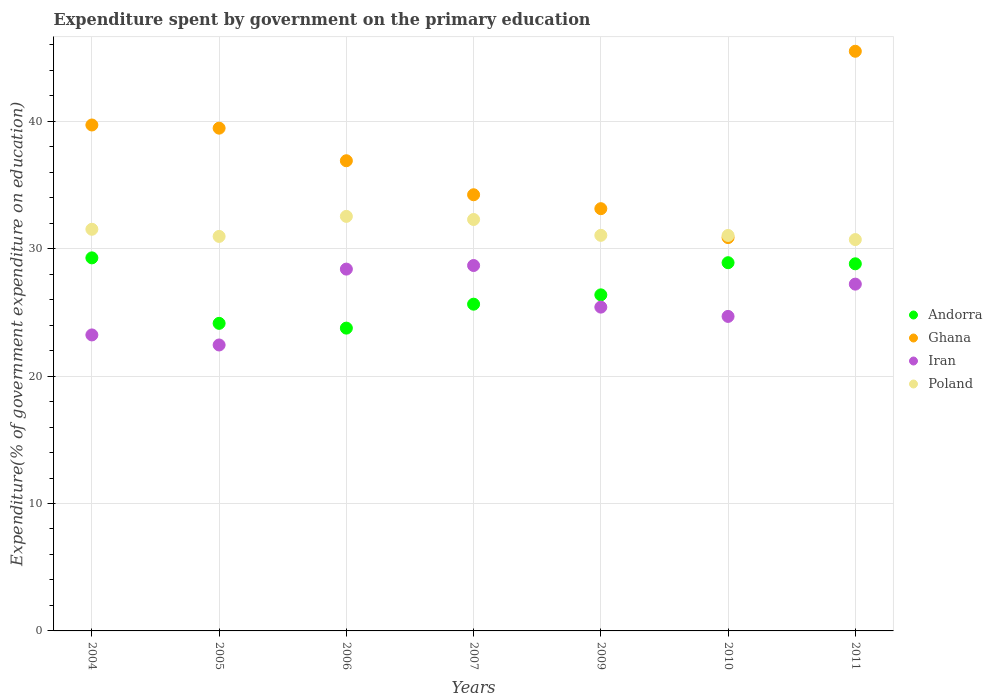What is the expenditure spent by government on the primary education in Iran in 2009?
Ensure brevity in your answer.  25.41. Across all years, what is the maximum expenditure spent by government on the primary education in Andorra?
Provide a succinct answer. 29.28. Across all years, what is the minimum expenditure spent by government on the primary education in Andorra?
Your response must be concise. 23.76. What is the total expenditure spent by government on the primary education in Ghana in the graph?
Your answer should be compact. 259.77. What is the difference between the expenditure spent by government on the primary education in Poland in 2005 and that in 2011?
Give a very brief answer. 0.25. What is the difference between the expenditure spent by government on the primary education in Andorra in 2011 and the expenditure spent by government on the primary education in Ghana in 2010?
Your answer should be compact. -2.06. What is the average expenditure spent by government on the primary education in Iran per year?
Your answer should be compact. 25.72. In the year 2007, what is the difference between the expenditure spent by government on the primary education in Poland and expenditure spent by government on the primary education in Andorra?
Offer a very short reply. 6.65. In how many years, is the expenditure spent by government on the primary education in Iran greater than 14 %?
Keep it short and to the point. 7. What is the ratio of the expenditure spent by government on the primary education in Iran in 2006 to that in 2011?
Keep it short and to the point. 1.04. What is the difference between the highest and the second highest expenditure spent by government on the primary education in Andorra?
Offer a very short reply. 0.38. What is the difference between the highest and the lowest expenditure spent by government on the primary education in Andorra?
Keep it short and to the point. 5.51. In how many years, is the expenditure spent by government on the primary education in Ghana greater than the average expenditure spent by government on the primary education in Ghana taken over all years?
Ensure brevity in your answer.  3. Is it the case that in every year, the sum of the expenditure spent by government on the primary education in Andorra and expenditure spent by government on the primary education in Iran  is greater than the sum of expenditure spent by government on the primary education in Ghana and expenditure spent by government on the primary education in Poland?
Your response must be concise. No. Is it the case that in every year, the sum of the expenditure spent by government on the primary education in Ghana and expenditure spent by government on the primary education in Andorra  is greater than the expenditure spent by government on the primary education in Poland?
Offer a terse response. Yes. Does the expenditure spent by government on the primary education in Poland monotonically increase over the years?
Offer a terse response. No. Is the expenditure spent by government on the primary education in Andorra strictly greater than the expenditure spent by government on the primary education in Ghana over the years?
Your answer should be very brief. No. Is the expenditure spent by government on the primary education in Poland strictly less than the expenditure spent by government on the primary education in Ghana over the years?
Provide a succinct answer. No. How many years are there in the graph?
Provide a succinct answer. 7. Are the values on the major ticks of Y-axis written in scientific E-notation?
Your answer should be compact. No. Does the graph contain any zero values?
Keep it short and to the point. No. Where does the legend appear in the graph?
Offer a terse response. Center right. How are the legend labels stacked?
Offer a very short reply. Vertical. What is the title of the graph?
Offer a terse response. Expenditure spent by government on the primary education. Does "Iraq" appear as one of the legend labels in the graph?
Your answer should be very brief. No. What is the label or title of the X-axis?
Your response must be concise. Years. What is the label or title of the Y-axis?
Ensure brevity in your answer.  Expenditure(% of government expenditure on education). What is the Expenditure(% of government expenditure on education) of Andorra in 2004?
Make the answer very short. 29.28. What is the Expenditure(% of government expenditure on education) of Ghana in 2004?
Your answer should be very brief. 39.7. What is the Expenditure(% of government expenditure on education) of Iran in 2004?
Keep it short and to the point. 23.23. What is the Expenditure(% of government expenditure on education) of Poland in 2004?
Ensure brevity in your answer.  31.52. What is the Expenditure(% of government expenditure on education) in Andorra in 2005?
Ensure brevity in your answer.  24.14. What is the Expenditure(% of government expenditure on education) of Ghana in 2005?
Provide a short and direct response. 39.45. What is the Expenditure(% of government expenditure on education) of Iran in 2005?
Provide a succinct answer. 22.44. What is the Expenditure(% of government expenditure on education) of Poland in 2005?
Ensure brevity in your answer.  30.96. What is the Expenditure(% of government expenditure on education) of Andorra in 2006?
Your response must be concise. 23.76. What is the Expenditure(% of government expenditure on education) in Ghana in 2006?
Provide a short and direct response. 36.9. What is the Expenditure(% of government expenditure on education) in Iran in 2006?
Make the answer very short. 28.39. What is the Expenditure(% of government expenditure on education) in Poland in 2006?
Make the answer very short. 32.53. What is the Expenditure(% of government expenditure on education) of Andorra in 2007?
Your answer should be compact. 25.64. What is the Expenditure(% of government expenditure on education) in Ghana in 2007?
Provide a short and direct response. 34.23. What is the Expenditure(% of government expenditure on education) of Iran in 2007?
Provide a succinct answer. 28.67. What is the Expenditure(% of government expenditure on education) in Poland in 2007?
Make the answer very short. 32.29. What is the Expenditure(% of government expenditure on education) in Andorra in 2009?
Offer a terse response. 26.37. What is the Expenditure(% of government expenditure on education) in Ghana in 2009?
Provide a succinct answer. 33.13. What is the Expenditure(% of government expenditure on education) in Iran in 2009?
Make the answer very short. 25.41. What is the Expenditure(% of government expenditure on education) in Poland in 2009?
Your response must be concise. 31.04. What is the Expenditure(% of government expenditure on education) in Andorra in 2010?
Keep it short and to the point. 28.9. What is the Expenditure(% of government expenditure on education) in Ghana in 2010?
Provide a succinct answer. 30.87. What is the Expenditure(% of government expenditure on education) in Iran in 2010?
Provide a short and direct response. 24.68. What is the Expenditure(% of government expenditure on education) of Poland in 2010?
Your response must be concise. 31.03. What is the Expenditure(% of government expenditure on education) in Andorra in 2011?
Ensure brevity in your answer.  28.81. What is the Expenditure(% of government expenditure on education) in Ghana in 2011?
Your answer should be compact. 45.49. What is the Expenditure(% of government expenditure on education) in Iran in 2011?
Make the answer very short. 27.21. What is the Expenditure(% of government expenditure on education) of Poland in 2011?
Keep it short and to the point. 30.71. Across all years, what is the maximum Expenditure(% of government expenditure on education) in Andorra?
Keep it short and to the point. 29.28. Across all years, what is the maximum Expenditure(% of government expenditure on education) in Ghana?
Your answer should be very brief. 45.49. Across all years, what is the maximum Expenditure(% of government expenditure on education) in Iran?
Keep it short and to the point. 28.67. Across all years, what is the maximum Expenditure(% of government expenditure on education) of Poland?
Provide a succinct answer. 32.53. Across all years, what is the minimum Expenditure(% of government expenditure on education) of Andorra?
Keep it short and to the point. 23.76. Across all years, what is the minimum Expenditure(% of government expenditure on education) of Ghana?
Your answer should be compact. 30.87. Across all years, what is the minimum Expenditure(% of government expenditure on education) of Iran?
Keep it short and to the point. 22.44. Across all years, what is the minimum Expenditure(% of government expenditure on education) in Poland?
Provide a short and direct response. 30.71. What is the total Expenditure(% of government expenditure on education) of Andorra in the graph?
Ensure brevity in your answer.  186.89. What is the total Expenditure(% of government expenditure on education) in Ghana in the graph?
Provide a succinct answer. 259.77. What is the total Expenditure(% of government expenditure on education) of Iran in the graph?
Your answer should be compact. 180.04. What is the total Expenditure(% of government expenditure on education) of Poland in the graph?
Ensure brevity in your answer.  220.08. What is the difference between the Expenditure(% of government expenditure on education) of Andorra in 2004 and that in 2005?
Keep it short and to the point. 5.14. What is the difference between the Expenditure(% of government expenditure on education) of Ghana in 2004 and that in 2005?
Your answer should be compact. 0.25. What is the difference between the Expenditure(% of government expenditure on education) of Iran in 2004 and that in 2005?
Offer a terse response. 0.79. What is the difference between the Expenditure(% of government expenditure on education) in Poland in 2004 and that in 2005?
Give a very brief answer. 0.56. What is the difference between the Expenditure(% of government expenditure on education) of Andorra in 2004 and that in 2006?
Give a very brief answer. 5.51. What is the difference between the Expenditure(% of government expenditure on education) in Ghana in 2004 and that in 2006?
Ensure brevity in your answer.  2.81. What is the difference between the Expenditure(% of government expenditure on education) of Iran in 2004 and that in 2006?
Ensure brevity in your answer.  -5.17. What is the difference between the Expenditure(% of government expenditure on education) of Poland in 2004 and that in 2006?
Offer a terse response. -1.01. What is the difference between the Expenditure(% of government expenditure on education) of Andorra in 2004 and that in 2007?
Offer a very short reply. 3.63. What is the difference between the Expenditure(% of government expenditure on education) of Ghana in 2004 and that in 2007?
Offer a very short reply. 5.47. What is the difference between the Expenditure(% of government expenditure on education) of Iran in 2004 and that in 2007?
Offer a very short reply. -5.45. What is the difference between the Expenditure(% of government expenditure on education) of Poland in 2004 and that in 2007?
Provide a short and direct response. -0.77. What is the difference between the Expenditure(% of government expenditure on education) in Andorra in 2004 and that in 2009?
Provide a succinct answer. 2.9. What is the difference between the Expenditure(% of government expenditure on education) in Ghana in 2004 and that in 2009?
Make the answer very short. 6.57. What is the difference between the Expenditure(% of government expenditure on education) in Iran in 2004 and that in 2009?
Keep it short and to the point. -2.18. What is the difference between the Expenditure(% of government expenditure on education) of Poland in 2004 and that in 2009?
Keep it short and to the point. 0.48. What is the difference between the Expenditure(% of government expenditure on education) in Andorra in 2004 and that in 2010?
Your answer should be very brief. 0.38. What is the difference between the Expenditure(% of government expenditure on education) of Ghana in 2004 and that in 2010?
Offer a very short reply. 8.84. What is the difference between the Expenditure(% of government expenditure on education) in Iran in 2004 and that in 2010?
Your answer should be compact. -1.45. What is the difference between the Expenditure(% of government expenditure on education) of Poland in 2004 and that in 2010?
Offer a terse response. 0.48. What is the difference between the Expenditure(% of government expenditure on education) in Andorra in 2004 and that in 2011?
Keep it short and to the point. 0.47. What is the difference between the Expenditure(% of government expenditure on education) in Ghana in 2004 and that in 2011?
Make the answer very short. -5.79. What is the difference between the Expenditure(% of government expenditure on education) of Iran in 2004 and that in 2011?
Keep it short and to the point. -3.99. What is the difference between the Expenditure(% of government expenditure on education) of Poland in 2004 and that in 2011?
Provide a short and direct response. 0.81. What is the difference between the Expenditure(% of government expenditure on education) of Andorra in 2005 and that in 2006?
Make the answer very short. 0.37. What is the difference between the Expenditure(% of government expenditure on education) of Ghana in 2005 and that in 2006?
Your answer should be very brief. 2.56. What is the difference between the Expenditure(% of government expenditure on education) of Iran in 2005 and that in 2006?
Offer a terse response. -5.95. What is the difference between the Expenditure(% of government expenditure on education) in Poland in 2005 and that in 2006?
Your answer should be very brief. -1.57. What is the difference between the Expenditure(% of government expenditure on education) of Andorra in 2005 and that in 2007?
Keep it short and to the point. -1.5. What is the difference between the Expenditure(% of government expenditure on education) in Ghana in 2005 and that in 2007?
Give a very brief answer. 5.23. What is the difference between the Expenditure(% of government expenditure on education) of Iran in 2005 and that in 2007?
Your answer should be very brief. -6.24. What is the difference between the Expenditure(% of government expenditure on education) in Poland in 2005 and that in 2007?
Offer a terse response. -1.33. What is the difference between the Expenditure(% of government expenditure on education) of Andorra in 2005 and that in 2009?
Your answer should be compact. -2.24. What is the difference between the Expenditure(% of government expenditure on education) of Ghana in 2005 and that in 2009?
Offer a very short reply. 6.32. What is the difference between the Expenditure(% of government expenditure on education) in Iran in 2005 and that in 2009?
Keep it short and to the point. -2.97. What is the difference between the Expenditure(% of government expenditure on education) of Poland in 2005 and that in 2009?
Make the answer very short. -0.08. What is the difference between the Expenditure(% of government expenditure on education) of Andorra in 2005 and that in 2010?
Offer a very short reply. -4.76. What is the difference between the Expenditure(% of government expenditure on education) of Ghana in 2005 and that in 2010?
Offer a terse response. 8.59. What is the difference between the Expenditure(% of government expenditure on education) in Iran in 2005 and that in 2010?
Your response must be concise. -2.24. What is the difference between the Expenditure(% of government expenditure on education) of Poland in 2005 and that in 2010?
Offer a terse response. -0.07. What is the difference between the Expenditure(% of government expenditure on education) of Andorra in 2005 and that in 2011?
Your answer should be compact. -4.67. What is the difference between the Expenditure(% of government expenditure on education) of Ghana in 2005 and that in 2011?
Give a very brief answer. -6.03. What is the difference between the Expenditure(% of government expenditure on education) in Iran in 2005 and that in 2011?
Your response must be concise. -4.77. What is the difference between the Expenditure(% of government expenditure on education) in Poland in 2005 and that in 2011?
Your answer should be compact. 0.25. What is the difference between the Expenditure(% of government expenditure on education) of Andorra in 2006 and that in 2007?
Keep it short and to the point. -1.88. What is the difference between the Expenditure(% of government expenditure on education) of Ghana in 2006 and that in 2007?
Give a very brief answer. 2.67. What is the difference between the Expenditure(% of government expenditure on education) of Iran in 2006 and that in 2007?
Make the answer very short. -0.28. What is the difference between the Expenditure(% of government expenditure on education) of Poland in 2006 and that in 2007?
Ensure brevity in your answer.  0.24. What is the difference between the Expenditure(% of government expenditure on education) in Andorra in 2006 and that in 2009?
Offer a very short reply. -2.61. What is the difference between the Expenditure(% of government expenditure on education) of Ghana in 2006 and that in 2009?
Ensure brevity in your answer.  3.76. What is the difference between the Expenditure(% of government expenditure on education) of Iran in 2006 and that in 2009?
Offer a very short reply. 2.98. What is the difference between the Expenditure(% of government expenditure on education) of Poland in 2006 and that in 2009?
Provide a succinct answer. 1.49. What is the difference between the Expenditure(% of government expenditure on education) of Andorra in 2006 and that in 2010?
Your response must be concise. -5.13. What is the difference between the Expenditure(% of government expenditure on education) in Ghana in 2006 and that in 2010?
Your answer should be very brief. 6.03. What is the difference between the Expenditure(% of government expenditure on education) in Iran in 2006 and that in 2010?
Provide a short and direct response. 3.71. What is the difference between the Expenditure(% of government expenditure on education) in Poland in 2006 and that in 2010?
Give a very brief answer. 1.5. What is the difference between the Expenditure(% of government expenditure on education) of Andorra in 2006 and that in 2011?
Keep it short and to the point. -5.05. What is the difference between the Expenditure(% of government expenditure on education) of Ghana in 2006 and that in 2011?
Keep it short and to the point. -8.59. What is the difference between the Expenditure(% of government expenditure on education) in Iran in 2006 and that in 2011?
Provide a succinct answer. 1.18. What is the difference between the Expenditure(% of government expenditure on education) in Poland in 2006 and that in 2011?
Your answer should be very brief. 1.82. What is the difference between the Expenditure(% of government expenditure on education) of Andorra in 2007 and that in 2009?
Ensure brevity in your answer.  -0.73. What is the difference between the Expenditure(% of government expenditure on education) of Ghana in 2007 and that in 2009?
Your answer should be compact. 1.09. What is the difference between the Expenditure(% of government expenditure on education) of Iran in 2007 and that in 2009?
Provide a short and direct response. 3.27. What is the difference between the Expenditure(% of government expenditure on education) in Poland in 2007 and that in 2009?
Your answer should be very brief. 1.24. What is the difference between the Expenditure(% of government expenditure on education) of Andorra in 2007 and that in 2010?
Provide a succinct answer. -3.25. What is the difference between the Expenditure(% of government expenditure on education) in Ghana in 2007 and that in 2010?
Give a very brief answer. 3.36. What is the difference between the Expenditure(% of government expenditure on education) in Iran in 2007 and that in 2010?
Give a very brief answer. 3.99. What is the difference between the Expenditure(% of government expenditure on education) of Poland in 2007 and that in 2010?
Keep it short and to the point. 1.25. What is the difference between the Expenditure(% of government expenditure on education) in Andorra in 2007 and that in 2011?
Your answer should be very brief. -3.17. What is the difference between the Expenditure(% of government expenditure on education) in Ghana in 2007 and that in 2011?
Give a very brief answer. -11.26. What is the difference between the Expenditure(% of government expenditure on education) of Iran in 2007 and that in 2011?
Make the answer very short. 1.46. What is the difference between the Expenditure(% of government expenditure on education) in Poland in 2007 and that in 2011?
Your answer should be compact. 1.58. What is the difference between the Expenditure(% of government expenditure on education) of Andorra in 2009 and that in 2010?
Offer a terse response. -2.52. What is the difference between the Expenditure(% of government expenditure on education) of Ghana in 2009 and that in 2010?
Ensure brevity in your answer.  2.27. What is the difference between the Expenditure(% of government expenditure on education) in Iran in 2009 and that in 2010?
Keep it short and to the point. 0.73. What is the difference between the Expenditure(% of government expenditure on education) of Poland in 2009 and that in 2010?
Provide a succinct answer. 0.01. What is the difference between the Expenditure(% of government expenditure on education) of Andorra in 2009 and that in 2011?
Your response must be concise. -2.44. What is the difference between the Expenditure(% of government expenditure on education) in Ghana in 2009 and that in 2011?
Ensure brevity in your answer.  -12.35. What is the difference between the Expenditure(% of government expenditure on education) of Iran in 2009 and that in 2011?
Offer a very short reply. -1.8. What is the difference between the Expenditure(% of government expenditure on education) of Poland in 2009 and that in 2011?
Offer a very short reply. 0.33. What is the difference between the Expenditure(% of government expenditure on education) in Andorra in 2010 and that in 2011?
Ensure brevity in your answer.  0.09. What is the difference between the Expenditure(% of government expenditure on education) in Ghana in 2010 and that in 2011?
Give a very brief answer. -14.62. What is the difference between the Expenditure(% of government expenditure on education) in Iran in 2010 and that in 2011?
Ensure brevity in your answer.  -2.53. What is the difference between the Expenditure(% of government expenditure on education) of Poland in 2010 and that in 2011?
Your answer should be compact. 0.32. What is the difference between the Expenditure(% of government expenditure on education) of Andorra in 2004 and the Expenditure(% of government expenditure on education) of Ghana in 2005?
Provide a succinct answer. -10.18. What is the difference between the Expenditure(% of government expenditure on education) in Andorra in 2004 and the Expenditure(% of government expenditure on education) in Iran in 2005?
Give a very brief answer. 6.84. What is the difference between the Expenditure(% of government expenditure on education) of Andorra in 2004 and the Expenditure(% of government expenditure on education) of Poland in 2005?
Your response must be concise. -1.68. What is the difference between the Expenditure(% of government expenditure on education) of Ghana in 2004 and the Expenditure(% of government expenditure on education) of Iran in 2005?
Keep it short and to the point. 17.26. What is the difference between the Expenditure(% of government expenditure on education) of Ghana in 2004 and the Expenditure(% of government expenditure on education) of Poland in 2005?
Your answer should be compact. 8.74. What is the difference between the Expenditure(% of government expenditure on education) in Iran in 2004 and the Expenditure(% of government expenditure on education) in Poland in 2005?
Ensure brevity in your answer.  -7.73. What is the difference between the Expenditure(% of government expenditure on education) in Andorra in 2004 and the Expenditure(% of government expenditure on education) in Ghana in 2006?
Ensure brevity in your answer.  -7.62. What is the difference between the Expenditure(% of government expenditure on education) in Andorra in 2004 and the Expenditure(% of government expenditure on education) in Iran in 2006?
Provide a short and direct response. 0.88. What is the difference between the Expenditure(% of government expenditure on education) in Andorra in 2004 and the Expenditure(% of government expenditure on education) in Poland in 2006?
Your response must be concise. -3.26. What is the difference between the Expenditure(% of government expenditure on education) in Ghana in 2004 and the Expenditure(% of government expenditure on education) in Iran in 2006?
Offer a terse response. 11.31. What is the difference between the Expenditure(% of government expenditure on education) in Ghana in 2004 and the Expenditure(% of government expenditure on education) in Poland in 2006?
Your response must be concise. 7.17. What is the difference between the Expenditure(% of government expenditure on education) in Iran in 2004 and the Expenditure(% of government expenditure on education) in Poland in 2006?
Ensure brevity in your answer.  -9.3. What is the difference between the Expenditure(% of government expenditure on education) of Andorra in 2004 and the Expenditure(% of government expenditure on education) of Ghana in 2007?
Provide a succinct answer. -4.95. What is the difference between the Expenditure(% of government expenditure on education) of Andorra in 2004 and the Expenditure(% of government expenditure on education) of Iran in 2007?
Provide a succinct answer. 0.6. What is the difference between the Expenditure(% of government expenditure on education) in Andorra in 2004 and the Expenditure(% of government expenditure on education) in Poland in 2007?
Ensure brevity in your answer.  -3.01. What is the difference between the Expenditure(% of government expenditure on education) in Ghana in 2004 and the Expenditure(% of government expenditure on education) in Iran in 2007?
Offer a terse response. 11.03. What is the difference between the Expenditure(% of government expenditure on education) of Ghana in 2004 and the Expenditure(% of government expenditure on education) of Poland in 2007?
Keep it short and to the point. 7.42. What is the difference between the Expenditure(% of government expenditure on education) in Iran in 2004 and the Expenditure(% of government expenditure on education) in Poland in 2007?
Give a very brief answer. -9.06. What is the difference between the Expenditure(% of government expenditure on education) of Andorra in 2004 and the Expenditure(% of government expenditure on education) of Ghana in 2009?
Ensure brevity in your answer.  -3.86. What is the difference between the Expenditure(% of government expenditure on education) in Andorra in 2004 and the Expenditure(% of government expenditure on education) in Iran in 2009?
Your answer should be compact. 3.87. What is the difference between the Expenditure(% of government expenditure on education) of Andorra in 2004 and the Expenditure(% of government expenditure on education) of Poland in 2009?
Offer a terse response. -1.77. What is the difference between the Expenditure(% of government expenditure on education) in Ghana in 2004 and the Expenditure(% of government expenditure on education) in Iran in 2009?
Give a very brief answer. 14.29. What is the difference between the Expenditure(% of government expenditure on education) of Ghana in 2004 and the Expenditure(% of government expenditure on education) of Poland in 2009?
Your answer should be compact. 8.66. What is the difference between the Expenditure(% of government expenditure on education) in Iran in 2004 and the Expenditure(% of government expenditure on education) in Poland in 2009?
Offer a very short reply. -7.82. What is the difference between the Expenditure(% of government expenditure on education) of Andorra in 2004 and the Expenditure(% of government expenditure on education) of Ghana in 2010?
Make the answer very short. -1.59. What is the difference between the Expenditure(% of government expenditure on education) in Andorra in 2004 and the Expenditure(% of government expenditure on education) in Iran in 2010?
Make the answer very short. 4.59. What is the difference between the Expenditure(% of government expenditure on education) of Andorra in 2004 and the Expenditure(% of government expenditure on education) of Poland in 2010?
Your answer should be compact. -1.76. What is the difference between the Expenditure(% of government expenditure on education) of Ghana in 2004 and the Expenditure(% of government expenditure on education) of Iran in 2010?
Your answer should be compact. 15.02. What is the difference between the Expenditure(% of government expenditure on education) in Ghana in 2004 and the Expenditure(% of government expenditure on education) in Poland in 2010?
Ensure brevity in your answer.  8.67. What is the difference between the Expenditure(% of government expenditure on education) in Iran in 2004 and the Expenditure(% of government expenditure on education) in Poland in 2010?
Provide a short and direct response. -7.81. What is the difference between the Expenditure(% of government expenditure on education) in Andorra in 2004 and the Expenditure(% of government expenditure on education) in Ghana in 2011?
Your answer should be very brief. -16.21. What is the difference between the Expenditure(% of government expenditure on education) of Andorra in 2004 and the Expenditure(% of government expenditure on education) of Iran in 2011?
Offer a very short reply. 2.06. What is the difference between the Expenditure(% of government expenditure on education) of Andorra in 2004 and the Expenditure(% of government expenditure on education) of Poland in 2011?
Make the answer very short. -1.44. What is the difference between the Expenditure(% of government expenditure on education) of Ghana in 2004 and the Expenditure(% of government expenditure on education) of Iran in 2011?
Provide a succinct answer. 12.49. What is the difference between the Expenditure(% of government expenditure on education) of Ghana in 2004 and the Expenditure(% of government expenditure on education) of Poland in 2011?
Your response must be concise. 8.99. What is the difference between the Expenditure(% of government expenditure on education) in Iran in 2004 and the Expenditure(% of government expenditure on education) in Poland in 2011?
Your answer should be compact. -7.48. What is the difference between the Expenditure(% of government expenditure on education) in Andorra in 2005 and the Expenditure(% of government expenditure on education) in Ghana in 2006?
Keep it short and to the point. -12.76. What is the difference between the Expenditure(% of government expenditure on education) in Andorra in 2005 and the Expenditure(% of government expenditure on education) in Iran in 2006?
Your answer should be very brief. -4.26. What is the difference between the Expenditure(% of government expenditure on education) in Andorra in 2005 and the Expenditure(% of government expenditure on education) in Poland in 2006?
Make the answer very short. -8.39. What is the difference between the Expenditure(% of government expenditure on education) in Ghana in 2005 and the Expenditure(% of government expenditure on education) in Iran in 2006?
Ensure brevity in your answer.  11.06. What is the difference between the Expenditure(% of government expenditure on education) of Ghana in 2005 and the Expenditure(% of government expenditure on education) of Poland in 2006?
Offer a terse response. 6.92. What is the difference between the Expenditure(% of government expenditure on education) in Iran in 2005 and the Expenditure(% of government expenditure on education) in Poland in 2006?
Offer a very short reply. -10.09. What is the difference between the Expenditure(% of government expenditure on education) of Andorra in 2005 and the Expenditure(% of government expenditure on education) of Ghana in 2007?
Provide a short and direct response. -10.09. What is the difference between the Expenditure(% of government expenditure on education) in Andorra in 2005 and the Expenditure(% of government expenditure on education) in Iran in 2007?
Ensure brevity in your answer.  -4.54. What is the difference between the Expenditure(% of government expenditure on education) in Andorra in 2005 and the Expenditure(% of government expenditure on education) in Poland in 2007?
Your answer should be compact. -8.15. What is the difference between the Expenditure(% of government expenditure on education) of Ghana in 2005 and the Expenditure(% of government expenditure on education) of Iran in 2007?
Provide a short and direct response. 10.78. What is the difference between the Expenditure(% of government expenditure on education) of Ghana in 2005 and the Expenditure(% of government expenditure on education) of Poland in 2007?
Offer a terse response. 7.17. What is the difference between the Expenditure(% of government expenditure on education) of Iran in 2005 and the Expenditure(% of government expenditure on education) of Poland in 2007?
Make the answer very short. -9.85. What is the difference between the Expenditure(% of government expenditure on education) in Andorra in 2005 and the Expenditure(% of government expenditure on education) in Ghana in 2009?
Offer a very short reply. -9. What is the difference between the Expenditure(% of government expenditure on education) of Andorra in 2005 and the Expenditure(% of government expenditure on education) of Iran in 2009?
Offer a very short reply. -1.27. What is the difference between the Expenditure(% of government expenditure on education) of Andorra in 2005 and the Expenditure(% of government expenditure on education) of Poland in 2009?
Provide a succinct answer. -6.91. What is the difference between the Expenditure(% of government expenditure on education) of Ghana in 2005 and the Expenditure(% of government expenditure on education) of Iran in 2009?
Offer a terse response. 14.04. What is the difference between the Expenditure(% of government expenditure on education) in Ghana in 2005 and the Expenditure(% of government expenditure on education) in Poland in 2009?
Provide a short and direct response. 8.41. What is the difference between the Expenditure(% of government expenditure on education) in Iran in 2005 and the Expenditure(% of government expenditure on education) in Poland in 2009?
Give a very brief answer. -8.6. What is the difference between the Expenditure(% of government expenditure on education) in Andorra in 2005 and the Expenditure(% of government expenditure on education) in Ghana in 2010?
Offer a terse response. -6.73. What is the difference between the Expenditure(% of government expenditure on education) in Andorra in 2005 and the Expenditure(% of government expenditure on education) in Iran in 2010?
Your answer should be very brief. -0.54. What is the difference between the Expenditure(% of government expenditure on education) of Andorra in 2005 and the Expenditure(% of government expenditure on education) of Poland in 2010?
Offer a terse response. -6.9. What is the difference between the Expenditure(% of government expenditure on education) in Ghana in 2005 and the Expenditure(% of government expenditure on education) in Iran in 2010?
Make the answer very short. 14.77. What is the difference between the Expenditure(% of government expenditure on education) of Ghana in 2005 and the Expenditure(% of government expenditure on education) of Poland in 2010?
Provide a short and direct response. 8.42. What is the difference between the Expenditure(% of government expenditure on education) in Iran in 2005 and the Expenditure(% of government expenditure on education) in Poland in 2010?
Make the answer very short. -8.59. What is the difference between the Expenditure(% of government expenditure on education) in Andorra in 2005 and the Expenditure(% of government expenditure on education) in Ghana in 2011?
Your answer should be compact. -21.35. What is the difference between the Expenditure(% of government expenditure on education) of Andorra in 2005 and the Expenditure(% of government expenditure on education) of Iran in 2011?
Your answer should be very brief. -3.08. What is the difference between the Expenditure(% of government expenditure on education) of Andorra in 2005 and the Expenditure(% of government expenditure on education) of Poland in 2011?
Ensure brevity in your answer.  -6.57. What is the difference between the Expenditure(% of government expenditure on education) of Ghana in 2005 and the Expenditure(% of government expenditure on education) of Iran in 2011?
Your response must be concise. 12.24. What is the difference between the Expenditure(% of government expenditure on education) in Ghana in 2005 and the Expenditure(% of government expenditure on education) in Poland in 2011?
Your answer should be compact. 8.74. What is the difference between the Expenditure(% of government expenditure on education) of Iran in 2005 and the Expenditure(% of government expenditure on education) of Poland in 2011?
Provide a succinct answer. -8.27. What is the difference between the Expenditure(% of government expenditure on education) of Andorra in 2006 and the Expenditure(% of government expenditure on education) of Ghana in 2007?
Keep it short and to the point. -10.47. What is the difference between the Expenditure(% of government expenditure on education) in Andorra in 2006 and the Expenditure(% of government expenditure on education) in Iran in 2007?
Offer a terse response. -4.91. What is the difference between the Expenditure(% of government expenditure on education) of Andorra in 2006 and the Expenditure(% of government expenditure on education) of Poland in 2007?
Provide a succinct answer. -8.53. What is the difference between the Expenditure(% of government expenditure on education) of Ghana in 2006 and the Expenditure(% of government expenditure on education) of Iran in 2007?
Your answer should be compact. 8.22. What is the difference between the Expenditure(% of government expenditure on education) in Ghana in 2006 and the Expenditure(% of government expenditure on education) in Poland in 2007?
Your answer should be very brief. 4.61. What is the difference between the Expenditure(% of government expenditure on education) in Iran in 2006 and the Expenditure(% of government expenditure on education) in Poland in 2007?
Your response must be concise. -3.89. What is the difference between the Expenditure(% of government expenditure on education) in Andorra in 2006 and the Expenditure(% of government expenditure on education) in Ghana in 2009?
Make the answer very short. -9.37. What is the difference between the Expenditure(% of government expenditure on education) in Andorra in 2006 and the Expenditure(% of government expenditure on education) in Iran in 2009?
Your answer should be very brief. -1.65. What is the difference between the Expenditure(% of government expenditure on education) of Andorra in 2006 and the Expenditure(% of government expenditure on education) of Poland in 2009?
Your response must be concise. -7.28. What is the difference between the Expenditure(% of government expenditure on education) in Ghana in 2006 and the Expenditure(% of government expenditure on education) in Iran in 2009?
Ensure brevity in your answer.  11.49. What is the difference between the Expenditure(% of government expenditure on education) in Ghana in 2006 and the Expenditure(% of government expenditure on education) in Poland in 2009?
Give a very brief answer. 5.85. What is the difference between the Expenditure(% of government expenditure on education) in Iran in 2006 and the Expenditure(% of government expenditure on education) in Poland in 2009?
Offer a very short reply. -2.65. What is the difference between the Expenditure(% of government expenditure on education) in Andorra in 2006 and the Expenditure(% of government expenditure on education) in Ghana in 2010?
Make the answer very short. -7.1. What is the difference between the Expenditure(% of government expenditure on education) of Andorra in 2006 and the Expenditure(% of government expenditure on education) of Iran in 2010?
Offer a very short reply. -0.92. What is the difference between the Expenditure(% of government expenditure on education) in Andorra in 2006 and the Expenditure(% of government expenditure on education) in Poland in 2010?
Ensure brevity in your answer.  -7.27. What is the difference between the Expenditure(% of government expenditure on education) in Ghana in 2006 and the Expenditure(% of government expenditure on education) in Iran in 2010?
Your answer should be compact. 12.22. What is the difference between the Expenditure(% of government expenditure on education) in Ghana in 2006 and the Expenditure(% of government expenditure on education) in Poland in 2010?
Ensure brevity in your answer.  5.86. What is the difference between the Expenditure(% of government expenditure on education) of Iran in 2006 and the Expenditure(% of government expenditure on education) of Poland in 2010?
Provide a short and direct response. -2.64. What is the difference between the Expenditure(% of government expenditure on education) of Andorra in 2006 and the Expenditure(% of government expenditure on education) of Ghana in 2011?
Provide a succinct answer. -21.73. What is the difference between the Expenditure(% of government expenditure on education) in Andorra in 2006 and the Expenditure(% of government expenditure on education) in Iran in 2011?
Ensure brevity in your answer.  -3.45. What is the difference between the Expenditure(% of government expenditure on education) in Andorra in 2006 and the Expenditure(% of government expenditure on education) in Poland in 2011?
Your answer should be very brief. -6.95. What is the difference between the Expenditure(% of government expenditure on education) in Ghana in 2006 and the Expenditure(% of government expenditure on education) in Iran in 2011?
Make the answer very short. 9.68. What is the difference between the Expenditure(% of government expenditure on education) in Ghana in 2006 and the Expenditure(% of government expenditure on education) in Poland in 2011?
Keep it short and to the point. 6.19. What is the difference between the Expenditure(% of government expenditure on education) in Iran in 2006 and the Expenditure(% of government expenditure on education) in Poland in 2011?
Your answer should be compact. -2.32. What is the difference between the Expenditure(% of government expenditure on education) of Andorra in 2007 and the Expenditure(% of government expenditure on education) of Ghana in 2009?
Make the answer very short. -7.49. What is the difference between the Expenditure(% of government expenditure on education) of Andorra in 2007 and the Expenditure(% of government expenditure on education) of Iran in 2009?
Make the answer very short. 0.23. What is the difference between the Expenditure(% of government expenditure on education) in Andorra in 2007 and the Expenditure(% of government expenditure on education) in Poland in 2009?
Keep it short and to the point. -5.4. What is the difference between the Expenditure(% of government expenditure on education) of Ghana in 2007 and the Expenditure(% of government expenditure on education) of Iran in 2009?
Provide a short and direct response. 8.82. What is the difference between the Expenditure(% of government expenditure on education) of Ghana in 2007 and the Expenditure(% of government expenditure on education) of Poland in 2009?
Your answer should be compact. 3.18. What is the difference between the Expenditure(% of government expenditure on education) of Iran in 2007 and the Expenditure(% of government expenditure on education) of Poland in 2009?
Offer a very short reply. -2.37. What is the difference between the Expenditure(% of government expenditure on education) of Andorra in 2007 and the Expenditure(% of government expenditure on education) of Ghana in 2010?
Offer a very short reply. -5.23. What is the difference between the Expenditure(% of government expenditure on education) of Andorra in 2007 and the Expenditure(% of government expenditure on education) of Iran in 2010?
Offer a terse response. 0.96. What is the difference between the Expenditure(% of government expenditure on education) in Andorra in 2007 and the Expenditure(% of government expenditure on education) in Poland in 2010?
Your answer should be very brief. -5.39. What is the difference between the Expenditure(% of government expenditure on education) in Ghana in 2007 and the Expenditure(% of government expenditure on education) in Iran in 2010?
Provide a short and direct response. 9.55. What is the difference between the Expenditure(% of government expenditure on education) in Ghana in 2007 and the Expenditure(% of government expenditure on education) in Poland in 2010?
Give a very brief answer. 3.19. What is the difference between the Expenditure(% of government expenditure on education) in Iran in 2007 and the Expenditure(% of government expenditure on education) in Poland in 2010?
Provide a short and direct response. -2.36. What is the difference between the Expenditure(% of government expenditure on education) in Andorra in 2007 and the Expenditure(% of government expenditure on education) in Ghana in 2011?
Offer a very short reply. -19.85. What is the difference between the Expenditure(% of government expenditure on education) in Andorra in 2007 and the Expenditure(% of government expenditure on education) in Iran in 2011?
Offer a very short reply. -1.57. What is the difference between the Expenditure(% of government expenditure on education) of Andorra in 2007 and the Expenditure(% of government expenditure on education) of Poland in 2011?
Your answer should be compact. -5.07. What is the difference between the Expenditure(% of government expenditure on education) of Ghana in 2007 and the Expenditure(% of government expenditure on education) of Iran in 2011?
Offer a terse response. 7.01. What is the difference between the Expenditure(% of government expenditure on education) in Ghana in 2007 and the Expenditure(% of government expenditure on education) in Poland in 2011?
Offer a very short reply. 3.52. What is the difference between the Expenditure(% of government expenditure on education) of Iran in 2007 and the Expenditure(% of government expenditure on education) of Poland in 2011?
Offer a very short reply. -2.04. What is the difference between the Expenditure(% of government expenditure on education) of Andorra in 2009 and the Expenditure(% of government expenditure on education) of Ghana in 2010?
Provide a short and direct response. -4.49. What is the difference between the Expenditure(% of government expenditure on education) in Andorra in 2009 and the Expenditure(% of government expenditure on education) in Iran in 2010?
Keep it short and to the point. 1.69. What is the difference between the Expenditure(% of government expenditure on education) of Andorra in 2009 and the Expenditure(% of government expenditure on education) of Poland in 2010?
Provide a succinct answer. -4.66. What is the difference between the Expenditure(% of government expenditure on education) of Ghana in 2009 and the Expenditure(% of government expenditure on education) of Iran in 2010?
Your answer should be compact. 8.45. What is the difference between the Expenditure(% of government expenditure on education) of Ghana in 2009 and the Expenditure(% of government expenditure on education) of Poland in 2010?
Keep it short and to the point. 2.1. What is the difference between the Expenditure(% of government expenditure on education) of Iran in 2009 and the Expenditure(% of government expenditure on education) of Poland in 2010?
Provide a succinct answer. -5.62. What is the difference between the Expenditure(% of government expenditure on education) of Andorra in 2009 and the Expenditure(% of government expenditure on education) of Ghana in 2011?
Ensure brevity in your answer.  -19.12. What is the difference between the Expenditure(% of government expenditure on education) in Andorra in 2009 and the Expenditure(% of government expenditure on education) in Iran in 2011?
Your response must be concise. -0.84. What is the difference between the Expenditure(% of government expenditure on education) of Andorra in 2009 and the Expenditure(% of government expenditure on education) of Poland in 2011?
Keep it short and to the point. -4.34. What is the difference between the Expenditure(% of government expenditure on education) in Ghana in 2009 and the Expenditure(% of government expenditure on education) in Iran in 2011?
Your answer should be compact. 5.92. What is the difference between the Expenditure(% of government expenditure on education) of Ghana in 2009 and the Expenditure(% of government expenditure on education) of Poland in 2011?
Provide a succinct answer. 2.42. What is the difference between the Expenditure(% of government expenditure on education) of Iran in 2009 and the Expenditure(% of government expenditure on education) of Poland in 2011?
Keep it short and to the point. -5.3. What is the difference between the Expenditure(% of government expenditure on education) of Andorra in 2010 and the Expenditure(% of government expenditure on education) of Ghana in 2011?
Ensure brevity in your answer.  -16.59. What is the difference between the Expenditure(% of government expenditure on education) in Andorra in 2010 and the Expenditure(% of government expenditure on education) in Iran in 2011?
Give a very brief answer. 1.68. What is the difference between the Expenditure(% of government expenditure on education) of Andorra in 2010 and the Expenditure(% of government expenditure on education) of Poland in 2011?
Your response must be concise. -1.82. What is the difference between the Expenditure(% of government expenditure on education) of Ghana in 2010 and the Expenditure(% of government expenditure on education) of Iran in 2011?
Your answer should be compact. 3.65. What is the difference between the Expenditure(% of government expenditure on education) in Ghana in 2010 and the Expenditure(% of government expenditure on education) in Poland in 2011?
Make the answer very short. 0.16. What is the difference between the Expenditure(% of government expenditure on education) of Iran in 2010 and the Expenditure(% of government expenditure on education) of Poland in 2011?
Make the answer very short. -6.03. What is the average Expenditure(% of government expenditure on education) in Andorra per year?
Make the answer very short. 26.7. What is the average Expenditure(% of government expenditure on education) in Ghana per year?
Provide a succinct answer. 37.11. What is the average Expenditure(% of government expenditure on education) of Iran per year?
Offer a terse response. 25.72. What is the average Expenditure(% of government expenditure on education) in Poland per year?
Your response must be concise. 31.44. In the year 2004, what is the difference between the Expenditure(% of government expenditure on education) in Andorra and Expenditure(% of government expenditure on education) in Ghana?
Provide a short and direct response. -10.43. In the year 2004, what is the difference between the Expenditure(% of government expenditure on education) in Andorra and Expenditure(% of government expenditure on education) in Iran?
Offer a terse response. 6.05. In the year 2004, what is the difference between the Expenditure(% of government expenditure on education) of Andorra and Expenditure(% of government expenditure on education) of Poland?
Your answer should be very brief. -2.24. In the year 2004, what is the difference between the Expenditure(% of government expenditure on education) in Ghana and Expenditure(% of government expenditure on education) in Iran?
Provide a succinct answer. 16.47. In the year 2004, what is the difference between the Expenditure(% of government expenditure on education) in Ghana and Expenditure(% of government expenditure on education) in Poland?
Keep it short and to the point. 8.18. In the year 2004, what is the difference between the Expenditure(% of government expenditure on education) of Iran and Expenditure(% of government expenditure on education) of Poland?
Provide a short and direct response. -8.29. In the year 2005, what is the difference between the Expenditure(% of government expenditure on education) of Andorra and Expenditure(% of government expenditure on education) of Ghana?
Your response must be concise. -15.32. In the year 2005, what is the difference between the Expenditure(% of government expenditure on education) of Andorra and Expenditure(% of government expenditure on education) of Iran?
Your answer should be compact. 1.7. In the year 2005, what is the difference between the Expenditure(% of government expenditure on education) of Andorra and Expenditure(% of government expenditure on education) of Poland?
Ensure brevity in your answer.  -6.82. In the year 2005, what is the difference between the Expenditure(% of government expenditure on education) in Ghana and Expenditure(% of government expenditure on education) in Iran?
Make the answer very short. 17.01. In the year 2005, what is the difference between the Expenditure(% of government expenditure on education) in Ghana and Expenditure(% of government expenditure on education) in Poland?
Provide a succinct answer. 8.49. In the year 2005, what is the difference between the Expenditure(% of government expenditure on education) in Iran and Expenditure(% of government expenditure on education) in Poland?
Make the answer very short. -8.52. In the year 2006, what is the difference between the Expenditure(% of government expenditure on education) in Andorra and Expenditure(% of government expenditure on education) in Ghana?
Provide a succinct answer. -13.14. In the year 2006, what is the difference between the Expenditure(% of government expenditure on education) in Andorra and Expenditure(% of government expenditure on education) in Iran?
Offer a terse response. -4.63. In the year 2006, what is the difference between the Expenditure(% of government expenditure on education) in Andorra and Expenditure(% of government expenditure on education) in Poland?
Your answer should be very brief. -8.77. In the year 2006, what is the difference between the Expenditure(% of government expenditure on education) of Ghana and Expenditure(% of government expenditure on education) of Iran?
Give a very brief answer. 8.5. In the year 2006, what is the difference between the Expenditure(% of government expenditure on education) of Ghana and Expenditure(% of government expenditure on education) of Poland?
Provide a succinct answer. 4.37. In the year 2006, what is the difference between the Expenditure(% of government expenditure on education) in Iran and Expenditure(% of government expenditure on education) in Poland?
Give a very brief answer. -4.14. In the year 2007, what is the difference between the Expenditure(% of government expenditure on education) of Andorra and Expenditure(% of government expenditure on education) of Ghana?
Provide a short and direct response. -8.59. In the year 2007, what is the difference between the Expenditure(% of government expenditure on education) in Andorra and Expenditure(% of government expenditure on education) in Iran?
Provide a succinct answer. -3.03. In the year 2007, what is the difference between the Expenditure(% of government expenditure on education) of Andorra and Expenditure(% of government expenditure on education) of Poland?
Ensure brevity in your answer.  -6.65. In the year 2007, what is the difference between the Expenditure(% of government expenditure on education) in Ghana and Expenditure(% of government expenditure on education) in Iran?
Your answer should be very brief. 5.55. In the year 2007, what is the difference between the Expenditure(% of government expenditure on education) of Ghana and Expenditure(% of government expenditure on education) of Poland?
Your response must be concise. 1.94. In the year 2007, what is the difference between the Expenditure(% of government expenditure on education) of Iran and Expenditure(% of government expenditure on education) of Poland?
Offer a very short reply. -3.61. In the year 2009, what is the difference between the Expenditure(% of government expenditure on education) in Andorra and Expenditure(% of government expenditure on education) in Ghana?
Keep it short and to the point. -6.76. In the year 2009, what is the difference between the Expenditure(% of government expenditure on education) of Andorra and Expenditure(% of government expenditure on education) of Iran?
Provide a succinct answer. 0.96. In the year 2009, what is the difference between the Expenditure(% of government expenditure on education) of Andorra and Expenditure(% of government expenditure on education) of Poland?
Make the answer very short. -4.67. In the year 2009, what is the difference between the Expenditure(% of government expenditure on education) of Ghana and Expenditure(% of government expenditure on education) of Iran?
Your answer should be compact. 7.73. In the year 2009, what is the difference between the Expenditure(% of government expenditure on education) in Ghana and Expenditure(% of government expenditure on education) in Poland?
Provide a succinct answer. 2.09. In the year 2009, what is the difference between the Expenditure(% of government expenditure on education) in Iran and Expenditure(% of government expenditure on education) in Poland?
Give a very brief answer. -5.63. In the year 2010, what is the difference between the Expenditure(% of government expenditure on education) of Andorra and Expenditure(% of government expenditure on education) of Ghana?
Keep it short and to the point. -1.97. In the year 2010, what is the difference between the Expenditure(% of government expenditure on education) in Andorra and Expenditure(% of government expenditure on education) in Iran?
Provide a succinct answer. 4.21. In the year 2010, what is the difference between the Expenditure(% of government expenditure on education) of Andorra and Expenditure(% of government expenditure on education) of Poland?
Offer a very short reply. -2.14. In the year 2010, what is the difference between the Expenditure(% of government expenditure on education) of Ghana and Expenditure(% of government expenditure on education) of Iran?
Your response must be concise. 6.19. In the year 2010, what is the difference between the Expenditure(% of government expenditure on education) in Ghana and Expenditure(% of government expenditure on education) in Poland?
Your answer should be very brief. -0.17. In the year 2010, what is the difference between the Expenditure(% of government expenditure on education) in Iran and Expenditure(% of government expenditure on education) in Poland?
Make the answer very short. -6.35. In the year 2011, what is the difference between the Expenditure(% of government expenditure on education) in Andorra and Expenditure(% of government expenditure on education) in Ghana?
Keep it short and to the point. -16.68. In the year 2011, what is the difference between the Expenditure(% of government expenditure on education) in Andorra and Expenditure(% of government expenditure on education) in Iran?
Provide a short and direct response. 1.59. In the year 2011, what is the difference between the Expenditure(% of government expenditure on education) in Andorra and Expenditure(% of government expenditure on education) in Poland?
Make the answer very short. -1.9. In the year 2011, what is the difference between the Expenditure(% of government expenditure on education) of Ghana and Expenditure(% of government expenditure on education) of Iran?
Offer a terse response. 18.27. In the year 2011, what is the difference between the Expenditure(% of government expenditure on education) in Ghana and Expenditure(% of government expenditure on education) in Poland?
Your answer should be compact. 14.78. In the year 2011, what is the difference between the Expenditure(% of government expenditure on education) of Iran and Expenditure(% of government expenditure on education) of Poland?
Your response must be concise. -3.5. What is the ratio of the Expenditure(% of government expenditure on education) of Andorra in 2004 to that in 2005?
Your answer should be compact. 1.21. What is the ratio of the Expenditure(% of government expenditure on education) in Ghana in 2004 to that in 2005?
Ensure brevity in your answer.  1.01. What is the ratio of the Expenditure(% of government expenditure on education) in Iran in 2004 to that in 2005?
Provide a short and direct response. 1.04. What is the ratio of the Expenditure(% of government expenditure on education) in Poland in 2004 to that in 2005?
Keep it short and to the point. 1.02. What is the ratio of the Expenditure(% of government expenditure on education) in Andorra in 2004 to that in 2006?
Make the answer very short. 1.23. What is the ratio of the Expenditure(% of government expenditure on education) of Ghana in 2004 to that in 2006?
Provide a short and direct response. 1.08. What is the ratio of the Expenditure(% of government expenditure on education) of Iran in 2004 to that in 2006?
Give a very brief answer. 0.82. What is the ratio of the Expenditure(% of government expenditure on education) in Poland in 2004 to that in 2006?
Offer a very short reply. 0.97. What is the ratio of the Expenditure(% of government expenditure on education) in Andorra in 2004 to that in 2007?
Your answer should be very brief. 1.14. What is the ratio of the Expenditure(% of government expenditure on education) in Ghana in 2004 to that in 2007?
Offer a very short reply. 1.16. What is the ratio of the Expenditure(% of government expenditure on education) in Iran in 2004 to that in 2007?
Your answer should be compact. 0.81. What is the ratio of the Expenditure(% of government expenditure on education) in Poland in 2004 to that in 2007?
Provide a short and direct response. 0.98. What is the ratio of the Expenditure(% of government expenditure on education) in Andorra in 2004 to that in 2009?
Your answer should be very brief. 1.11. What is the ratio of the Expenditure(% of government expenditure on education) in Ghana in 2004 to that in 2009?
Make the answer very short. 1.2. What is the ratio of the Expenditure(% of government expenditure on education) in Iran in 2004 to that in 2009?
Your answer should be compact. 0.91. What is the ratio of the Expenditure(% of government expenditure on education) in Poland in 2004 to that in 2009?
Make the answer very short. 1.02. What is the ratio of the Expenditure(% of government expenditure on education) of Andorra in 2004 to that in 2010?
Provide a short and direct response. 1.01. What is the ratio of the Expenditure(% of government expenditure on education) of Ghana in 2004 to that in 2010?
Give a very brief answer. 1.29. What is the ratio of the Expenditure(% of government expenditure on education) of Iran in 2004 to that in 2010?
Offer a very short reply. 0.94. What is the ratio of the Expenditure(% of government expenditure on education) of Poland in 2004 to that in 2010?
Your answer should be very brief. 1.02. What is the ratio of the Expenditure(% of government expenditure on education) of Andorra in 2004 to that in 2011?
Give a very brief answer. 1.02. What is the ratio of the Expenditure(% of government expenditure on education) of Ghana in 2004 to that in 2011?
Give a very brief answer. 0.87. What is the ratio of the Expenditure(% of government expenditure on education) of Iran in 2004 to that in 2011?
Your answer should be compact. 0.85. What is the ratio of the Expenditure(% of government expenditure on education) in Poland in 2004 to that in 2011?
Offer a very short reply. 1.03. What is the ratio of the Expenditure(% of government expenditure on education) in Andorra in 2005 to that in 2006?
Provide a short and direct response. 1.02. What is the ratio of the Expenditure(% of government expenditure on education) of Ghana in 2005 to that in 2006?
Provide a succinct answer. 1.07. What is the ratio of the Expenditure(% of government expenditure on education) of Iran in 2005 to that in 2006?
Provide a short and direct response. 0.79. What is the ratio of the Expenditure(% of government expenditure on education) of Poland in 2005 to that in 2006?
Provide a succinct answer. 0.95. What is the ratio of the Expenditure(% of government expenditure on education) in Andorra in 2005 to that in 2007?
Your answer should be compact. 0.94. What is the ratio of the Expenditure(% of government expenditure on education) in Ghana in 2005 to that in 2007?
Give a very brief answer. 1.15. What is the ratio of the Expenditure(% of government expenditure on education) in Iran in 2005 to that in 2007?
Provide a short and direct response. 0.78. What is the ratio of the Expenditure(% of government expenditure on education) in Poland in 2005 to that in 2007?
Ensure brevity in your answer.  0.96. What is the ratio of the Expenditure(% of government expenditure on education) in Andorra in 2005 to that in 2009?
Keep it short and to the point. 0.92. What is the ratio of the Expenditure(% of government expenditure on education) in Ghana in 2005 to that in 2009?
Your answer should be compact. 1.19. What is the ratio of the Expenditure(% of government expenditure on education) in Iran in 2005 to that in 2009?
Make the answer very short. 0.88. What is the ratio of the Expenditure(% of government expenditure on education) in Poland in 2005 to that in 2009?
Give a very brief answer. 1. What is the ratio of the Expenditure(% of government expenditure on education) of Andorra in 2005 to that in 2010?
Your answer should be very brief. 0.84. What is the ratio of the Expenditure(% of government expenditure on education) in Ghana in 2005 to that in 2010?
Your response must be concise. 1.28. What is the ratio of the Expenditure(% of government expenditure on education) in Iran in 2005 to that in 2010?
Ensure brevity in your answer.  0.91. What is the ratio of the Expenditure(% of government expenditure on education) of Poland in 2005 to that in 2010?
Make the answer very short. 1. What is the ratio of the Expenditure(% of government expenditure on education) in Andorra in 2005 to that in 2011?
Keep it short and to the point. 0.84. What is the ratio of the Expenditure(% of government expenditure on education) in Ghana in 2005 to that in 2011?
Offer a very short reply. 0.87. What is the ratio of the Expenditure(% of government expenditure on education) in Iran in 2005 to that in 2011?
Make the answer very short. 0.82. What is the ratio of the Expenditure(% of government expenditure on education) in Poland in 2005 to that in 2011?
Your response must be concise. 1.01. What is the ratio of the Expenditure(% of government expenditure on education) of Andorra in 2006 to that in 2007?
Give a very brief answer. 0.93. What is the ratio of the Expenditure(% of government expenditure on education) of Ghana in 2006 to that in 2007?
Give a very brief answer. 1.08. What is the ratio of the Expenditure(% of government expenditure on education) in Iran in 2006 to that in 2007?
Provide a succinct answer. 0.99. What is the ratio of the Expenditure(% of government expenditure on education) of Poland in 2006 to that in 2007?
Keep it short and to the point. 1.01. What is the ratio of the Expenditure(% of government expenditure on education) in Andorra in 2006 to that in 2009?
Give a very brief answer. 0.9. What is the ratio of the Expenditure(% of government expenditure on education) of Ghana in 2006 to that in 2009?
Give a very brief answer. 1.11. What is the ratio of the Expenditure(% of government expenditure on education) of Iran in 2006 to that in 2009?
Offer a terse response. 1.12. What is the ratio of the Expenditure(% of government expenditure on education) of Poland in 2006 to that in 2009?
Offer a very short reply. 1.05. What is the ratio of the Expenditure(% of government expenditure on education) of Andorra in 2006 to that in 2010?
Offer a very short reply. 0.82. What is the ratio of the Expenditure(% of government expenditure on education) of Ghana in 2006 to that in 2010?
Your response must be concise. 1.2. What is the ratio of the Expenditure(% of government expenditure on education) in Iran in 2006 to that in 2010?
Your answer should be compact. 1.15. What is the ratio of the Expenditure(% of government expenditure on education) of Poland in 2006 to that in 2010?
Your answer should be compact. 1.05. What is the ratio of the Expenditure(% of government expenditure on education) of Andorra in 2006 to that in 2011?
Offer a terse response. 0.82. What is the ratio of the Expenditure(% of government expenditure on education) of Ghana in 2006 to that in 2011?
Provide a short and direct response. 0.81. What is the ratio of the Expenditure(% of government expenditure on education) in Iran in 2006 to that in 2011?
Your answer should be very brief. 1.04. What is the ratio of the Expenditure(% of government expenditure on education) of Poland in 2006 to that in 2011?
Make the answer very short. 1.06. What is the ratio of the Expenditure(% of government expenditure on education) in Andorra in 2007 to that in 2009?
Keep it short and to the point. 0.97. What is the ratio of the Expenditure(% of government expenditure on education) of Ghana in 2007 to that in 2009?
Offer a terse response. 1.03. What is the ratio of the Expenditure(% of government expenditure on education) in Iran in 2007 to that in 2009?
Give a very brief answer. 1.13. What is the ratio of the Expenditure(% of government expenditure on education) of Poland in 2007 to that in 2009?
Keep it short and to the point. 1.04. What is the ratio of the Expenditure(% of government expenditure on education) of Andorra in 2007 to that in 2010?
Your response must be concise. 0.89. What is the ratio of the Expenditure(% of government expenditure on education) in Ghana in 2007 to that in 2010?
Keep it short and to the point. 1.11. What is the ratio of the Expenditure(% of government expenditure on education) of Iran in 2007 to that in 2010?
Offer a very short reply. 1.16. What is the ratio of the Expenditure(% of government expenditure on education) of Poland in 2007 to that in 2010?
Give a very brief answer. 1.04. What is the ratio of the Expenditure(% of government expenditure on education) in Andorra in 2007 to that in 2011?
Make the answer very short. 0.89. What is the ratio of the Expenditure(% of government expenditure on education) in Ghana in 2007 to that in 2011?
Your response must be concise. 0.75. What is the ratio of the Expenditure(% of government expenditure on education) in Iran in 2007 to that in 2011?
Your response must be concise. 1.05. What is the ratio of the Expenditure(% of government expenditure on education) in Poland in 2007 to that in 2011?
Offer a terse response. 1.05. What is the ratio of the Expenditure(% of government expenditure on education) in Andorra in 2009 to that in 2010?
Make the answer very short. 0.91. What is the ratio of the Expenditure(% of government expenditure on education) in Ghana in 2009 to that in 2010?
Provide a succinct answer. 1.07. What is the ratio of the Expenditure(% of government expenditure on education) in Iran in 2009 to that in 2010?
Offer a very short reply. 1.03. What is the ratio of the Expenditure(% of government expenditure on education) of Poland in 2009 to that in 2010?
Make the answer very short. 1. What is the ratio of the Expenditure(% of government expenditure on education) in Andorra in 2009 to that in 2011?
Make the answer very short. 0.92. What is the ratio of the Expenditure(% of government expenditure on education) of Ghana in 2009 to that in 2011?
Offer a terse response. 0.73. What is the ratio of the Expenditure(% of government expenditure on education) in Iran in 2009 to that in 2011?
Your response must be concise. 0.93. What is the ratio of the Expenditure(% of government expenditure on education) in Poland in 2009 to that in 2011?
Ensure brevity in your answer.  1.01. What is the ratio of the Expenditure(% of government expenditure on education) of Andorra in 2010 to that in 2011?
Your answer should be very brief. 1. What is the ratio of the Expenditure(% of government expenditure on education) in Ghana in 2010 to that in 2011?
Your answer should be very brief. 0.68. What is the ratio of the Expenditure(% of government expenditure on education) in Iran in 2010 to that in 2011?
Keep it short and to the point. 0.91. What is the ratio of the Expenditure(% of government expenditure on education) of Poland in 2010 to that in 2011?
Offer a terse response. 1.01. What is the difference between the highest and the second highest Expenditure(% of government expenditure on education) in Andorra?
Make the answer very short. 0.38. What is the difference between the highest and the second highest Expenditure(% of government expenditure on education) in Ghana?
Provide a succinct answer. 5.79. What is the difference between the highest and the second highest Expenditure(% of government expenditure on education) in Iran?
Your response must be concise. 0.28. What is the difference between the highest and the second highest Expenditure(% of government expenditure on education) of Poland?
Your response must be concise. 0.24. What is the difference between the highest and the lowest Expenditure(% of government expenditure on education) in Andorra?
Offer a very short reply. 5.51. What is the difference between the highest and the lowest Expenditure(% of government expenditure on education) in Ghana?
Your answer should be very brief. 14.62. What is the difference between the highest and the lowest Expenditure(% of government expenditure on education) in Iran?
Make the answer very short. 6.24. What is the difference between the highest and the lowest Expenditure(% of government expenditure on education) in Poland?
Offer a terse response. 1.82. 